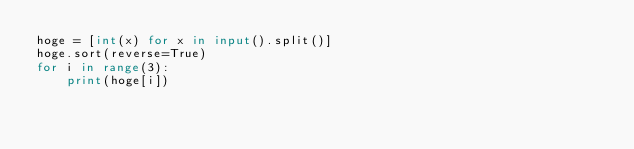<code> <loc_0><loc_0><loc_500><loc_500><_Python_>hoge = [int(x) for x in input().split()]
hoge.sort(reverse=True)
for i in range(3):
    print(hoge[i])</code> 